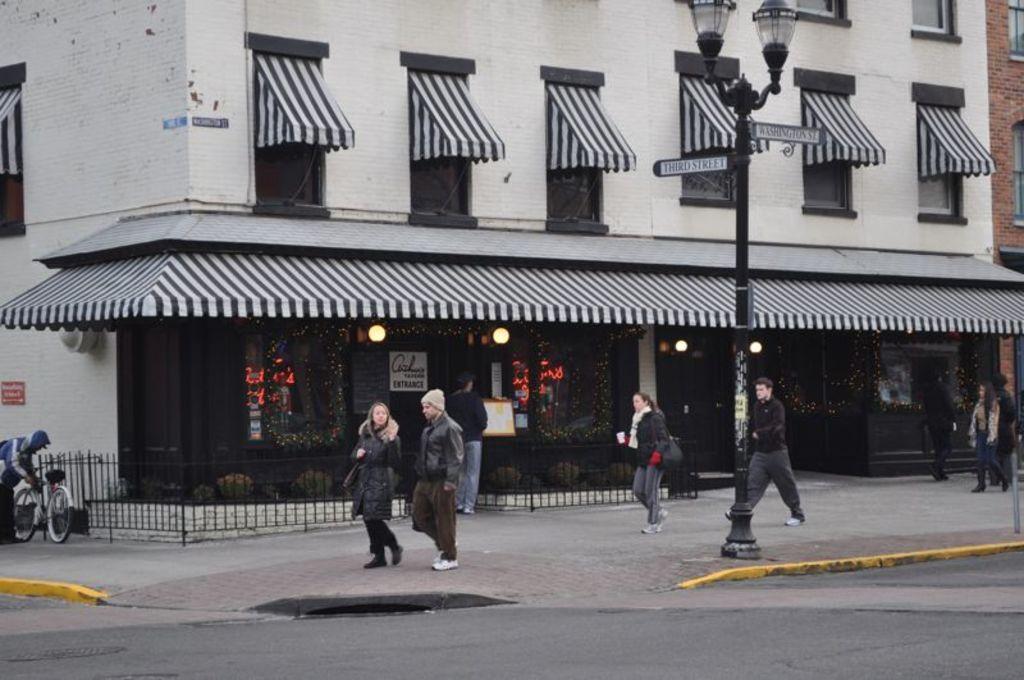Could you give a brief overview of what you see in this image? In this image I can see here few people are working on the foot path. It looks like a store, there are lights in it. In the middle there are street lamps, on the left side a man is holding the bicycle. 